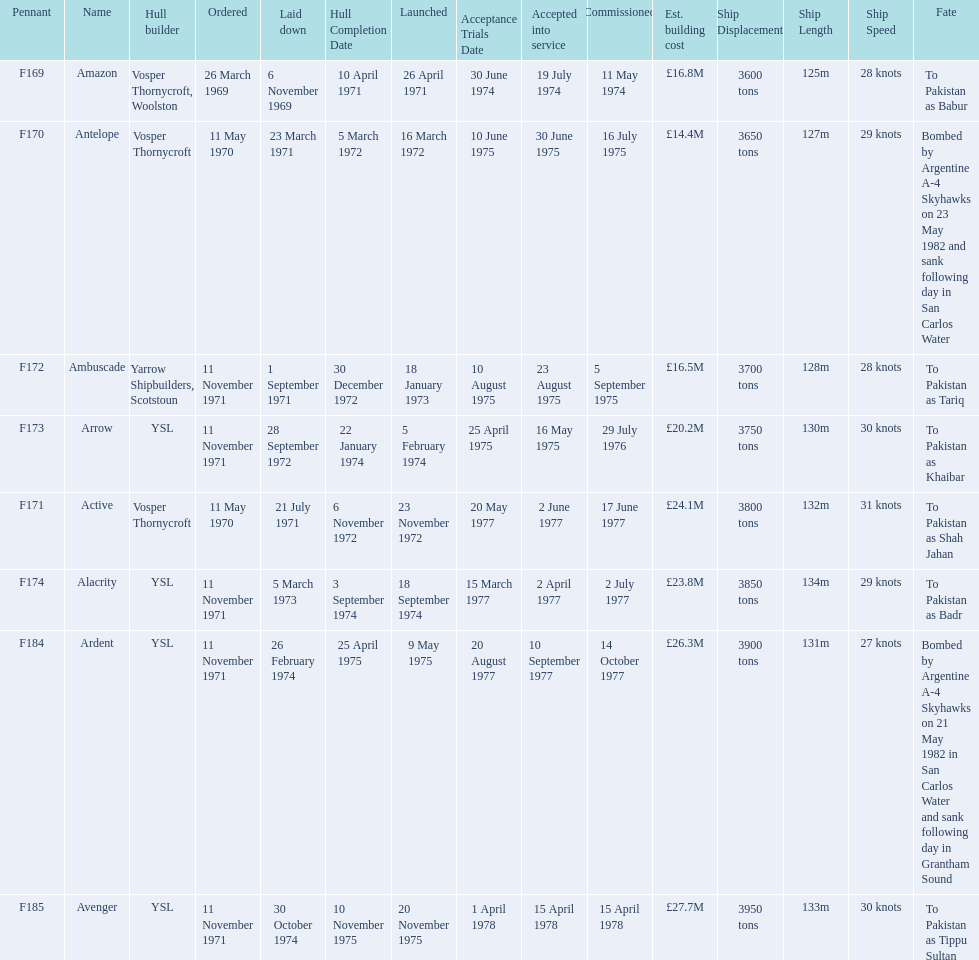Which ships cost more than ps25.0m to build? Ardent, Avenger. Of the ships listed in the answer above, which one cost the most to build? Avenger. 